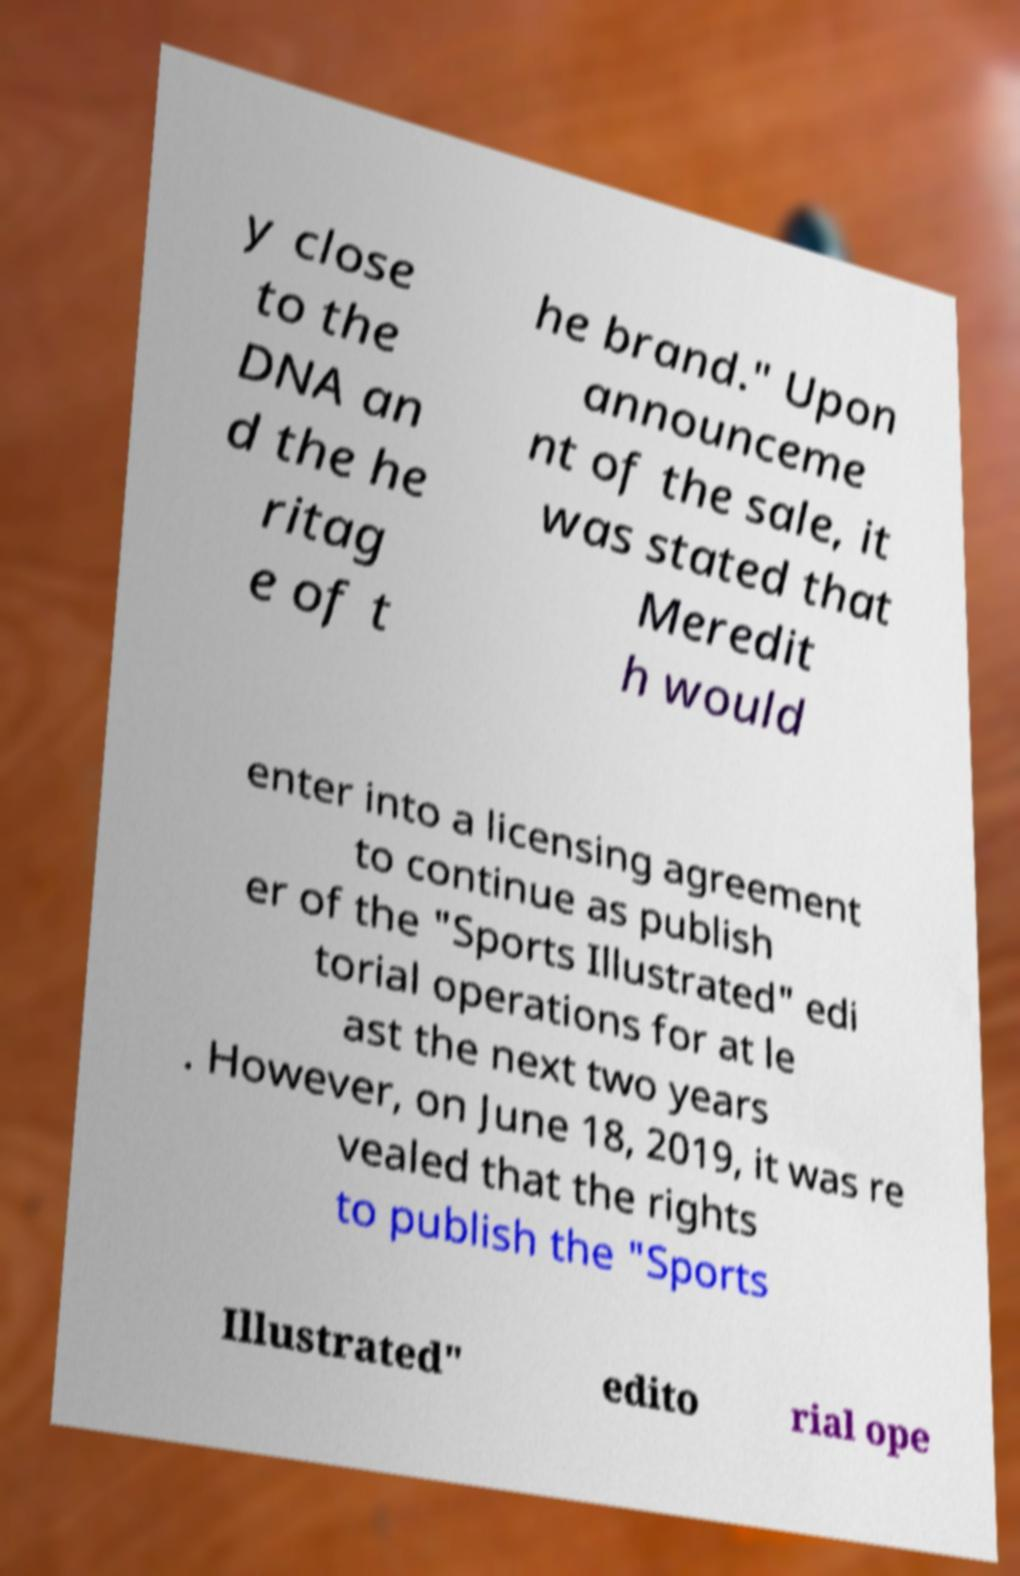Can you read and provide the text displayed in the image?This photo seems to have some interesting text. Can you extract and type it out for me? y close to the DNA an d the he ritag e of t he brand." Upon announceme nt of the sale, it was stated that Meredit h would enter into a licensing agreement to continue as publish er of the "Sports Illustrated" edi torial operations for at le ast the next two years . However, on June 18, 2019, it was re vealed that the rights to publish the "Sports Illustrated" edito rial ope 